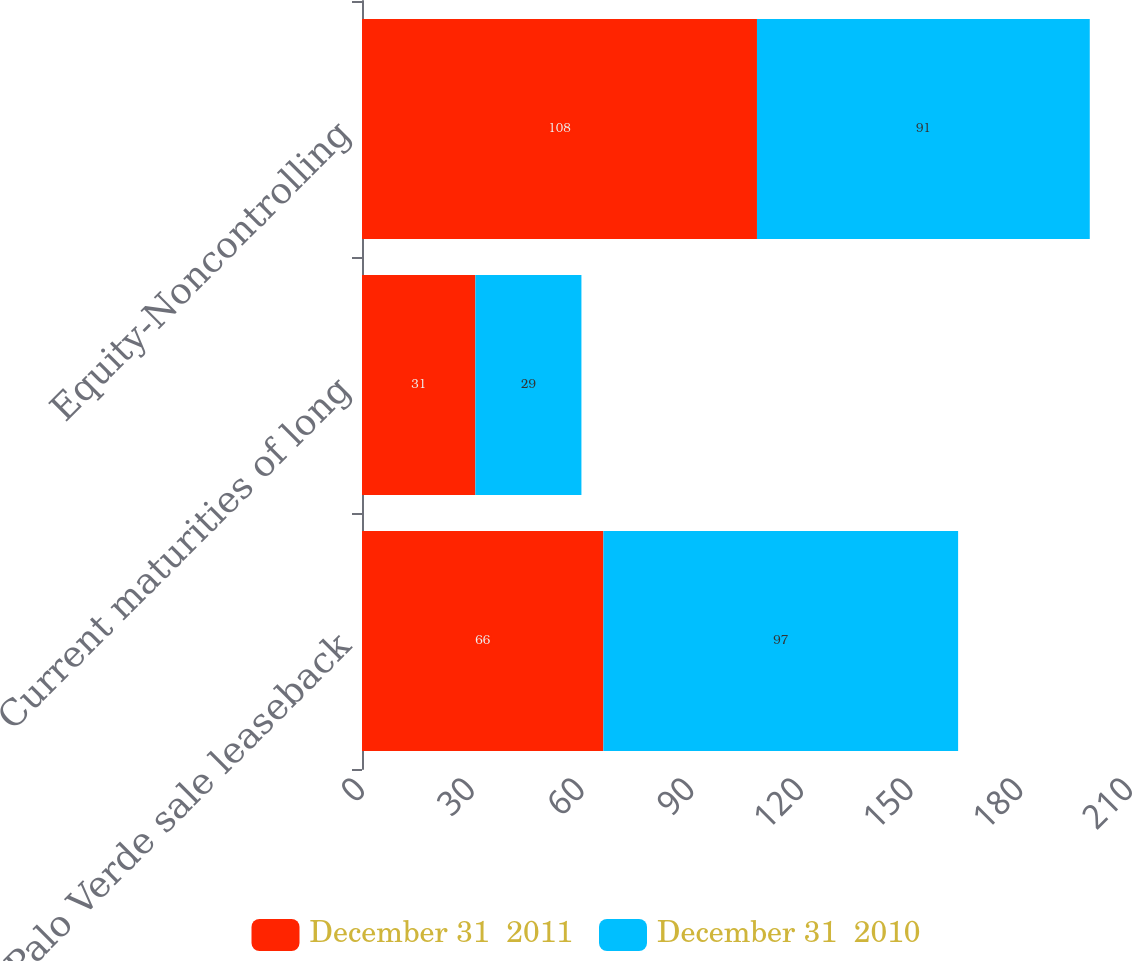Convert chart to OTSL. <chart><loc_0><loc_0><loc_500><loc_500><stacked_bar_chart><ecel><fcel>Palo Verde sale leaseback<fcel>Current maturities of long<fcel>Equity-Noncontrolling<nl><fcel>December 31  2011<fcel>66<fcel>31<fcel>108<nl><fcel>December 31  2010<fcel>97<fcel>29<fcel>91<nl></chart> 